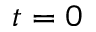Convert formula to latex. <formula><loc_0><loc_0><loc_500><loc_500>t = 0</formula> 